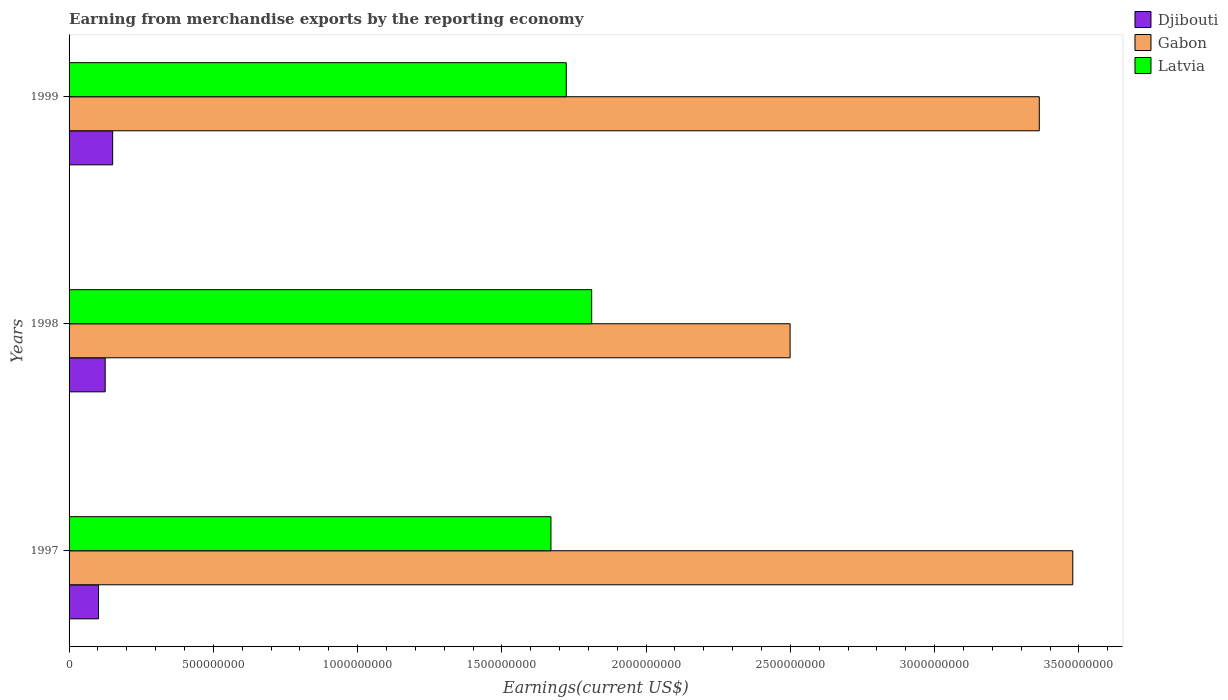How many groups of bars are there?
Your answer should be very brief. 3. Are the number of bars on each tick of the Y-axis equal?
Provide a succinct answer. Yes. How many bars are there on the 1st tick from the top?
Provide a short and direct response. 3. What is the label of the 2nd group of bars from the top?
Give a very brief answer. 1998. In how many cases, is the number of bars for a given year not equal to the number of legend labels?
Give a very brief answer. 0. What is the amount earned from merchandise exports in Latvia in 1999?
Your response must be concise. 1.72e+09. Across all years, what is the maximum amount earned from merchandise exports in Gabon?
Your response must be concise. 3.48e+09. Across all years, what is the minimum amount earned from merchandise exports in Djibouti?
Make the answer very short. 1.02e+08. What is the total amount earned from merchandise exports in Djibouti in the graph?
Provide a short and direct response. 3.78e+08. What is the difference between the amount earned from merchandise exports in Latvia in 1998 and that in 1999?
Your answer should be very brief. 8.81e+07. What is the difference between the amount earned from merchandise exports in Djibouti in 1997 and the amount earned from merchandise exports in Latvia in 1999?
Your answer should be very brief. -1.62e+09. What is the average amount earned from merchandise exports in Gabon per year?
Provide a short and direct response. 3.11e+09. In the year 1999, what is the difference between the amount earned from merchandise exports in Latvia and amount earned from merchandise exports in Djibouti?
Keep it short and to the point. 1.57e+09. In how many years, is the amount earned from merchandise exports in Latvia greater than 500000000 US$?
Offer a very short reply. 3. What is the ratio of the amount earned from merchandise exports in Latvia in 1997 to that in 1998?
Make the answer very short. 0.92. What is the difference between the highest and the second highest amount earned from merchandise exports in Gabon?
Your answer should be compact. 1.16e+08. What is the difference between the highest and the lowest amount earned from merchandise exports in Djibouti?
Your answer should be very brief. 4.91e+07. Is the sum of the amount earned from merchandise exports in Gabon in 1997 and 1999 greater than the maximum amount earned from merchandise exports in Latvia across all years?
Your answer should be compact. Yes. What does the 1st bar from the top in 1999 represents?
Offer a terse response. Latvia. What does the 3rd bar from the bottom in 1999 represents?
Your answer should be very brief. Latvia. Is it the case that in every year, the sum of the amount earned from merchandise exports in Gabon and amount earned from merchandise exports in Djibouti is greater than the amount earned from merchandise exports in Latvia?
Provide a succinct answer. Yes. How many bars are there?
Make the answer very short. 9. Are all the bars in the graph horizontal?
Provide a short and direct response. Yes. How many years are there in the graph?
Keep it short and to the point. 3. Does the graph contain any zero values?
Offer a very short reply. No. Does the graph contain grids?
Provide a short and direct response. No. How many legend labels are there?
Ensure brevity in your answer.  3. What is the title of the graph?
Keep it short and to the point. Earning from merchandise exports by the reporting economy. What is the label or title of the X-axis?
Offer a very short reply. Earnings(current US$). What is the Earnings(current US$) of Djibouti in 1997?
Your response must be concise. 1.02e+08. What is the Earnings(current US$) of Gabon in 1997?
Offer a terse response. 3.48e+09. What is the Earnings(current US$) in Latvia in 1997?
Your answer should be very brief. 1.67e+09. What is the Earnings(current US$) in Djibouti in 1998?
Ensure brevity in your answer.  1.25e+08. What is the Earnings(current US$) of Gabon in 1998?
Your response must be concise. 2.50e+09. What is the Earnings(current US$) of Latvia in 1998?
Offer a terse response. 1.81e+09. What is the Earnings(current US$) in Djibouti in 1999?
Ensure brevity in your answer.  1.51e+08. What is the Earnings(current US$) of Gabon in 1999?
Make the answer very short. 3.36e+09. What is the Earnings(current US$) of Latvia in 1999?
Your answer should be very brief. 1.72e+09. Across all years, what is the maximum Earnings(current US$) of Djibouti?
Keep it short and to the point. 1.51e+08. Across all years, what is the maximum Earnings(current US$) of Gabon?
Offer a terse response. 3.48e+09. Across all years, what is the maximum Earnings(current US$) in Latvia?
Keep it short and to the point. 1.81e+09. Across all years, what is the minimum Earnings(current US$) in Djibouti?
Your response must be concise. 1.02e+08. Across all years, what is the minimum Earnings(current US$) in Gabon?
Give a very brief answer. 2.50e+09. Across all years, what is the minimum Earnings(current US$) in Latvia?
Your answer should be compact. 1.67e+09. What is the total Earnings(current US$) of Djibouti in the graph?
Provide a short and direct response. 3.78e+08. What is the total Earnings(current US$) in Gabon in the graph?
Your answer should be very brief. 9.34e+09. What is the total Earnings(current US$) of Latvia in the graph?
Provide a succinct answer. 5.20e+09. What is the difference between the Earnings(current US$) in Djibouti in 1997 and that in 1998?
Your answer should be very brief. -2.32e+07. What is the difference between the Earnings(current US$) of Gabon in 1997 and that in 1998?
Provide a succinct answer. 9.80e+08. What is the difference between the Earnings(current US$) of Latvia in 1997 and that in 1998?
Ensure brevity in your answer.  -1.41e+08. What is the difference between the Earnings(current US$) of Djibouti in 1997 and that in 1999?
Provide a short and direct response. -4.91e+07. What is the difference between the Earnings(current US$) of Gabon in 1997 and that in 1999?
Provide a succinct answer. 1.16e+08. What is the difference between the Earnings(current US$) of Latvia in 1997 and that in 1999?
Provide a succinct answer. -5.31e+07. What is the difference between the Earnings(current US$) in Djibouti in 1998 and that in 1999?
Give a very brief answer. -2.59e+07. What is the difference between the Earnings(current US$) of Gabon in 1998 and that in 1999?
Keep it short and to the point. -8.64e+08. What is the difference between the Earnings(current US$) in Latvia in 1998 and that in 1999?
Offer a very short reply. 8.81e+07. What is the difference between the Earnings(current US$) of Djibouti in 1997 and the Earnings(current US$) of Gabon in 1998?
Your answer should be compact. -2.40e+09. What is the difference between the Earnings(current US$) of Djibouti in 1997 and the Earnings(current US$) of Latvia in 1998?
Give a very brief answer. -1.71e+09. What is the difference between the Earnings(current US$) in Gabon in 1997 and the Earnings(current US$) in Latvia in 1998?
Offer a terse response. 1.67e+09. What is the difference between the Earnings(current US$) of Djibouti in 1997 and the Earnings(current US$) of Gabon in 1999?
Make the answer very short. -3.26e+09. What is the difference between the Earnings(current US$) of Djibouti in 1997 and the Earnings(current US$) of Latvia in 1999?
Keep it short and to the point. -1.62e+09. What is the difference between the Earnings(current US$) in Gabon in 1997 and the Earnings(current US$) in Latvia in 1999?
Offer a terse response. 1.76e+09. What is the difference between the Earnings(current US$) of Djibouti in 1998 and the Earnings(current US$) of Gabon in 1999?
Keep it short and to the point. -3.24e+09. What is the difference between the Earnings(current US$) in Djibouti in 1998 and the Earnings(current US$) in Latvia in 1999?
Provide a succinct answer. -1.60e+09. What is the difference between the Earnings(current US$) of Gabon in 1998 and the Earnings(current US$) of Latvia in 1999?
Your answer should be compact. 7.76e+08. What is the average Earnings(current US$) in Djibouti per year?
Provide a succinct answer. 1.26e+08. What is the average Earnings(current US$) of Gabon per year?
Keep it short and to the point. 3.11e+09. What is the average Earnings(current US$) in Latvia per year?
Ensure brevity in your answer.  1.73e+09. In the year 1997, what is the difference between the Earnings(current US$) of Djibouti and Earnings(current US$) of Gabon?
Your answer should be very brief. -3.38e+09. In the year 1997, what is the difference between the Earnings(current US$) in Djibouti and Earnings(current US$) in Latvia?
Your answer should be very brief. -1.57e+09. In the year 1997, what is the difference between the Earnings(current US$) in Gabon and Earnings(current US$) in Latvia?
Provide a succinct answer. 1.81e+09. In the year 1998, what is the difference between the Earnings(current US$) in Djibouti and Earnings(current US$) in Gabon?
Your answer should be compact. -2.37e+09. In the year 1998, what is the difference between the Earnings(current US$) in Djibouti and Earnings(current US$) in Latvia?
Provide a short and direct response. -1.69e+09. In the year 1998, what is the difference between the Earnings(current US$) in Gabon and Earnings(current US$) in Latvia?
Your response must be concise. 6.88e+08. In the year 1999, what is the difference between the Earnings(current US$) of Djibouti and Earnings(current US$) of Gabon?
Make the answer very short. -3.21e+09. In the year 1999, what is the difference between the Earnings(current US$) in Djibouti and Earnings(current US$) in Latvia?
Your answer should be very brief. -1.57e+09. In the year 1999, what is the difference between the Earnings(current US$) of Gabon and Earnings(current US$) of Latvia?
Make the answer very short. 1.64e+09. What is the ratio of the Earnings(current US$) of Djibouti in 1997 to that in 1998?
Ensure brevity in your answer.  0.81. What is the ratio of the Earnings(current US$) of Gabon in 1997 to that in 1998?
Provide a short and direct response. 1.39. What is the ratio of the Earnings(current US$) in Latvia in 1997 to that in 1998?
Your response must be concise. 0.92. What is the ratio of the Earnings(current US$) of Djibouti in 1997 to that in 1999?
Provide a succinct answer. 0.68. What is the ratio of the Earnings(current US$) of Gabon in 1997 to that in 1999?
Keep it short and to the point. 1.03. What is the ratio of the Earnings(current US$) of Latvia in 1997 to that in 1999?
Your response must be concise. 0.97. What is the ratio of the Earnings(current US$) of Djibouti in 1998 to that in 1999?
Make the answer very short. 0.83. What is the ratio of the Earnings(current US$) in Gabon in 1998 to that in 1999?
Your answer should be compact. 0.74. What is the ratio of the Earnings(current US$) in Latvia in 1998 to that in 1999?
Provide a short and direct response. 1.05. What is the difference between the highest and the second highest Earnings(current US$) of Djibouti?
Give a very brief answer. 2.59e+07. What is the difference between the highest and the second highest Earnings(current US$) of Gabon?
Provide a short and direct response. 1.16e+08. What is the difference between the highest and the second highest Earnings(current US$) of Latvia?
Provide a short and direct response. 8.81e+07. What is the difference between the highest and the lowest Earnings(current US$) in Djibouti?
Make the answer very short. 4.91e+07. What is the difference between the highest and the lowest Earnings(current US$) of Gabon?
Make the answer very short. 9.80e+08. What is the difference between the highest and the lowest Earnings(current US$) of Latvia?
Your answer should be compact. 1.41e+08. 